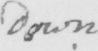Can you tell me what this handwritten text says? down 